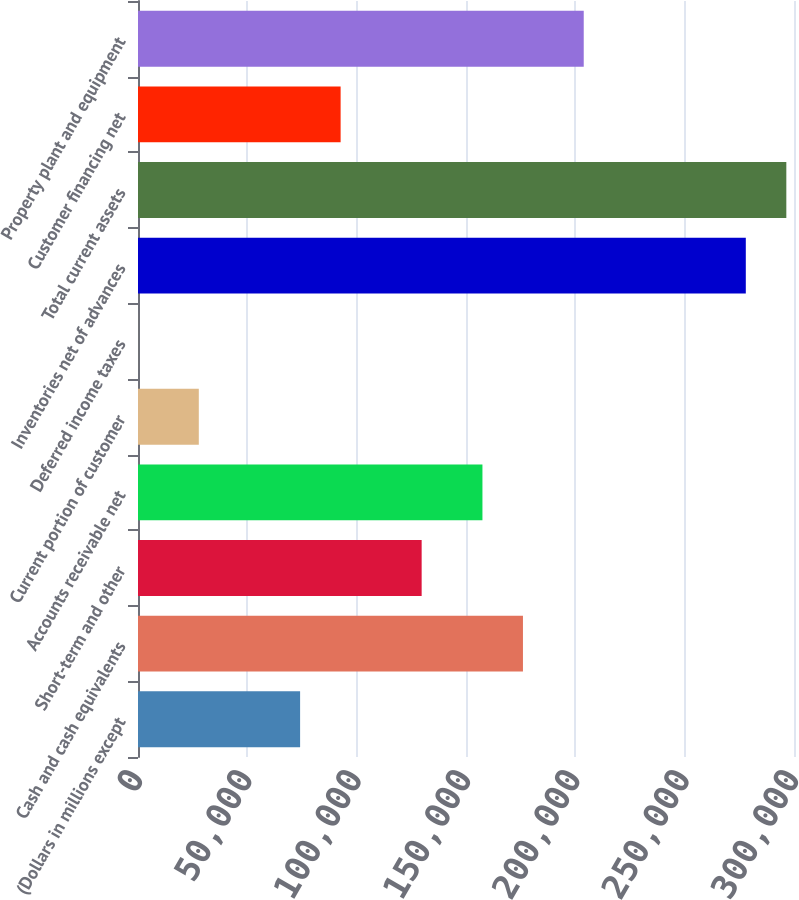Convert chart to OTSL. <chart><loc_0><loc_0><loc_500><loc_500><bar_chart><fcel>(Dollars in millions except<fcel>Cash and cash equivalents<fcel>Short-term and other<fcel>Accounts receivable net<fcel>Current portion of customer<fcel>Deferred income taxes<fcel>Inventories net of advances<fcel>Total current assets<fcel>Customer financing net<fcel>Property plant and equipment<nl><fcel>74133.2<fcel>176047<fcel>129723<fcel>157517<fcel>27808.7<fcel>14<fcel>277961<fcel>296491<fcel>92663<fcel>203842<nl></chart> 